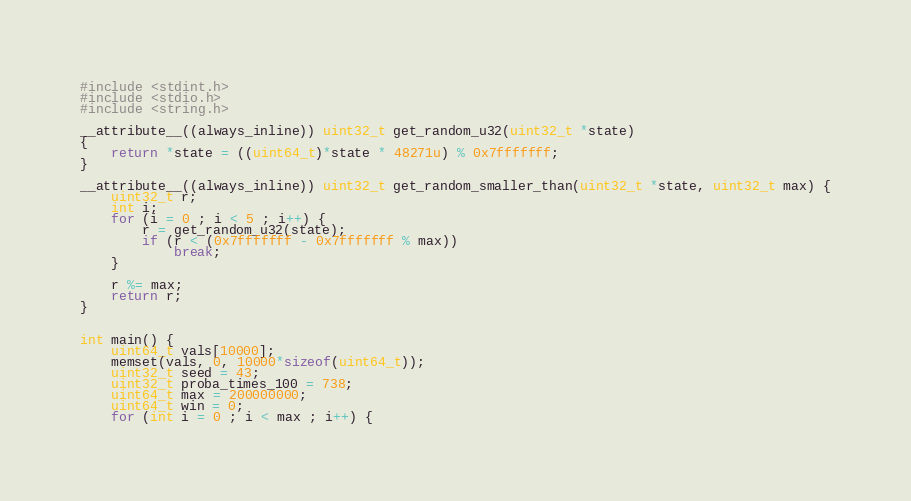Convert code to text. <code><loc_0><loc_0><loc_500><loc_500><_C_>#include <stdint.h>
#include <stdio.h>
#include <string.h>

__attribute__((always_inline)) uint32_t get_random_u32(uint32_t *state)
{
    return *state = ((uint64_t)*state * 48271u) % 0x7fffffff;
}

__attribute__((always_inline)) uint32_t get_random_smaller_than(uint32_t *state, uint32_t max) {
    uint32_t r;
    int i;
    for (i = 0 ; i < 5 ; i++) {
        r = get_random_u32(state);
        if (r < (0x7fffffff - 0x7fffffff % max))
            break;
    }

    r %= max;
    return r;
}


int main() {
    uint64_t vals[10000];
    memset(vals, 0, 10000*sizeof(uint64_t));
    uint32_t seed = 43;
    uint32_t proba_times_100 = 738;
    uint64_t max = 200000000;
    uint64_t win = 0;
    for (int i = 0 ; i < max ; i++) {</code> 